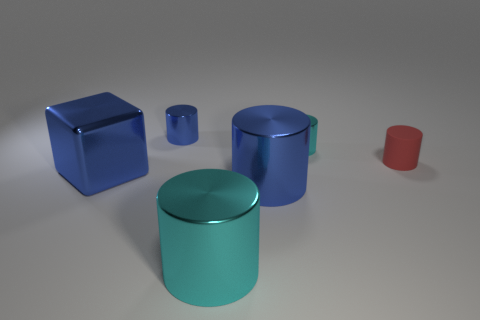Subtract all red cylinders. How many cylinders are left? 4 Subtract all small matte cylinders. How many cylinders are left? 4 Subtract all gray cylinders. Subtract all yellow cubes. How many cylinders are left? 5 Add 4 small brown things. How many objects exist? 10 Subtract all cylinders. How many objects are left? 1 Add 2 small blue cylinders. How many small blue cylinders exist? 3 Subtract 0 green cubes. How many objects are left? 6 Subtract all metallic cylinders. Subtract all red objects. How many objects are left? 1 Add 5 cyan cylinders. How many cyan cylinders are left? 7 